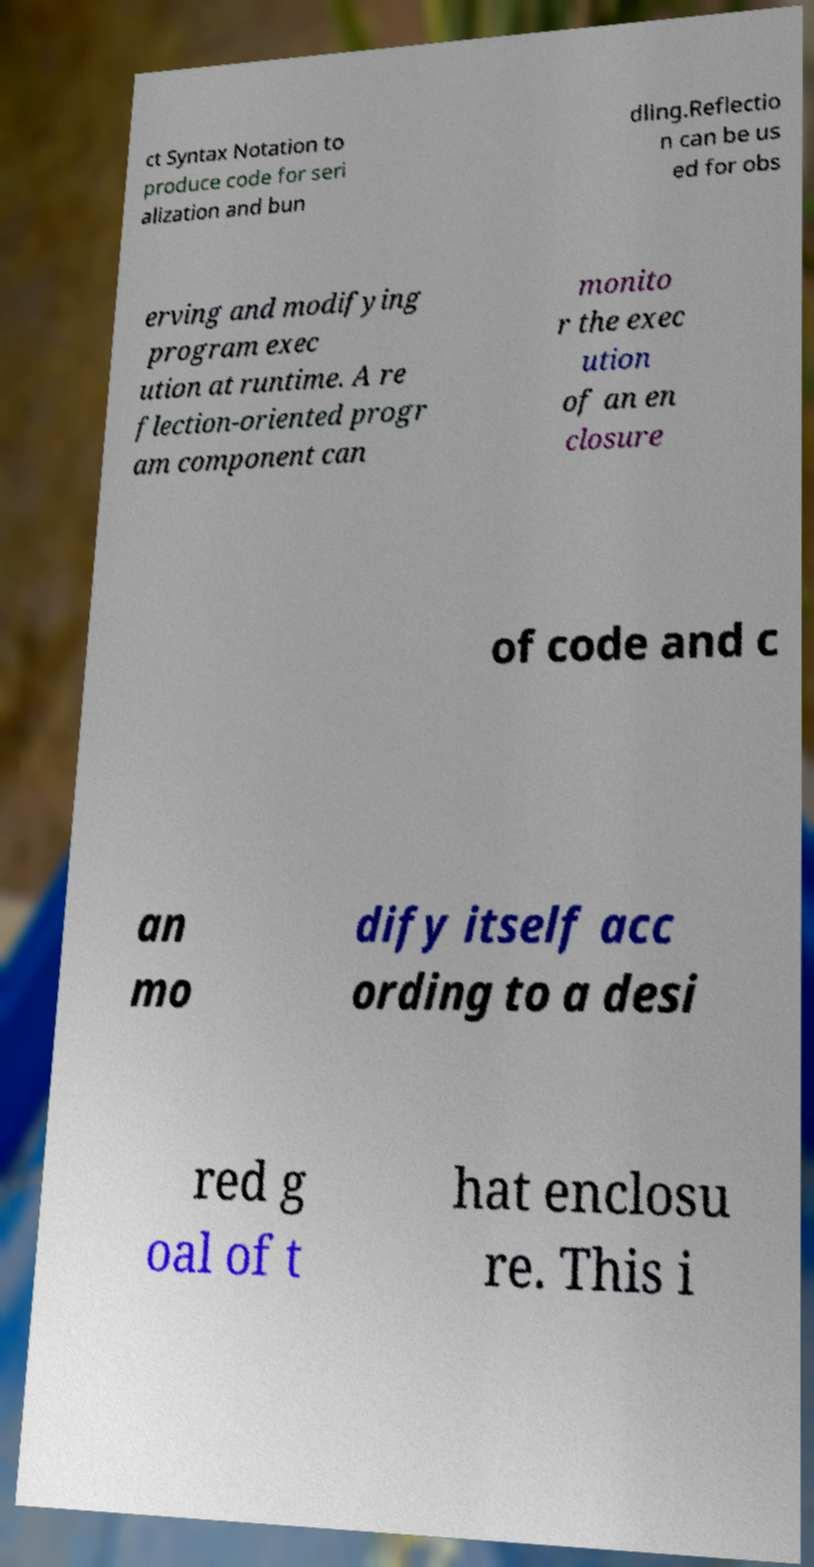Please read and relay the text visible in this image. What does it say? ct Syntax Notation to produce code for seri alization and bun dling.Reflectio n can be us ed for obs erving and modifying program exec ution at runtime. A re flection-oriented progr am component can monito r the exec ution of an en closure of code and c an mo dify itself acc ording to a desi red g oal of t hat enclosu re. This i 